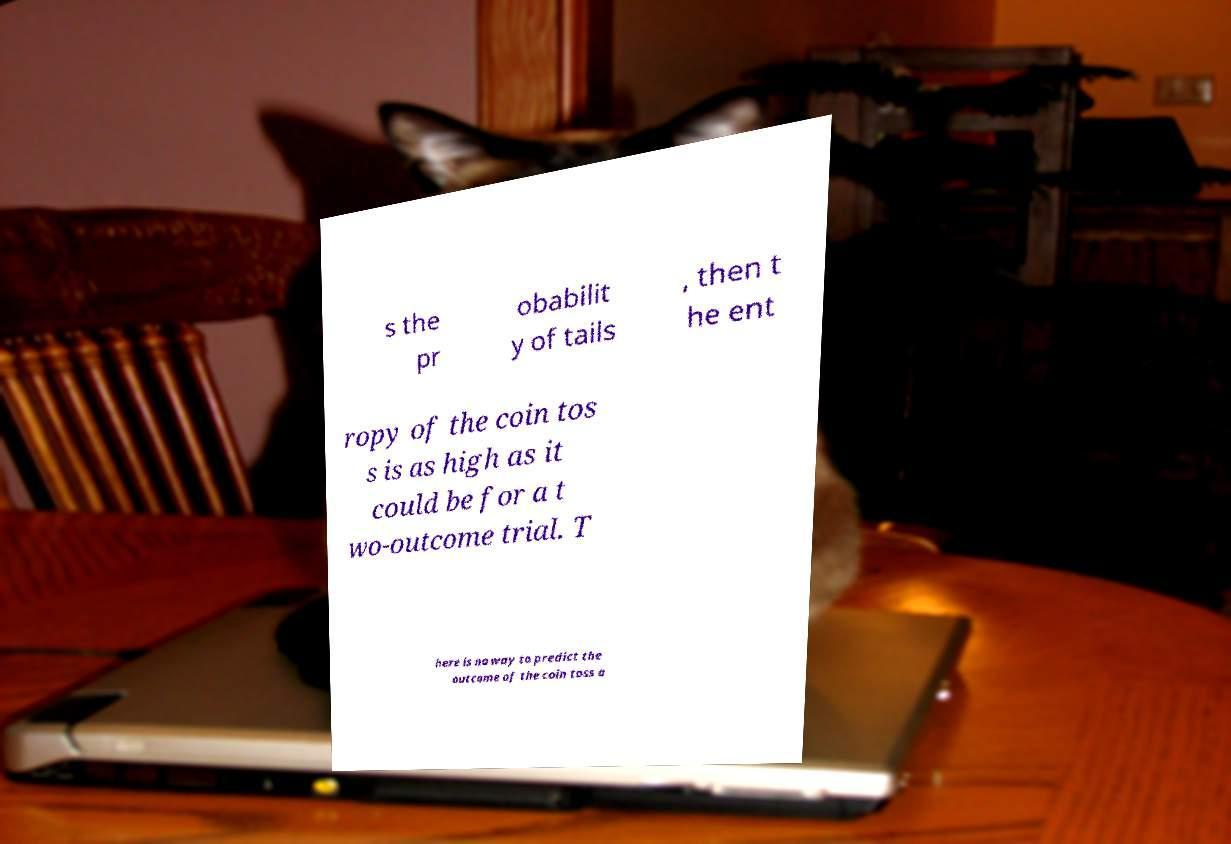Could you assist in decoding the text presented in this image and type it out clearly? s the pr obabilit y of tails , then t he ent ropy of the coin tos s is as high as it could be for a t wo-outcome trial. T here is no way to predict the outcome of the coin toss a 